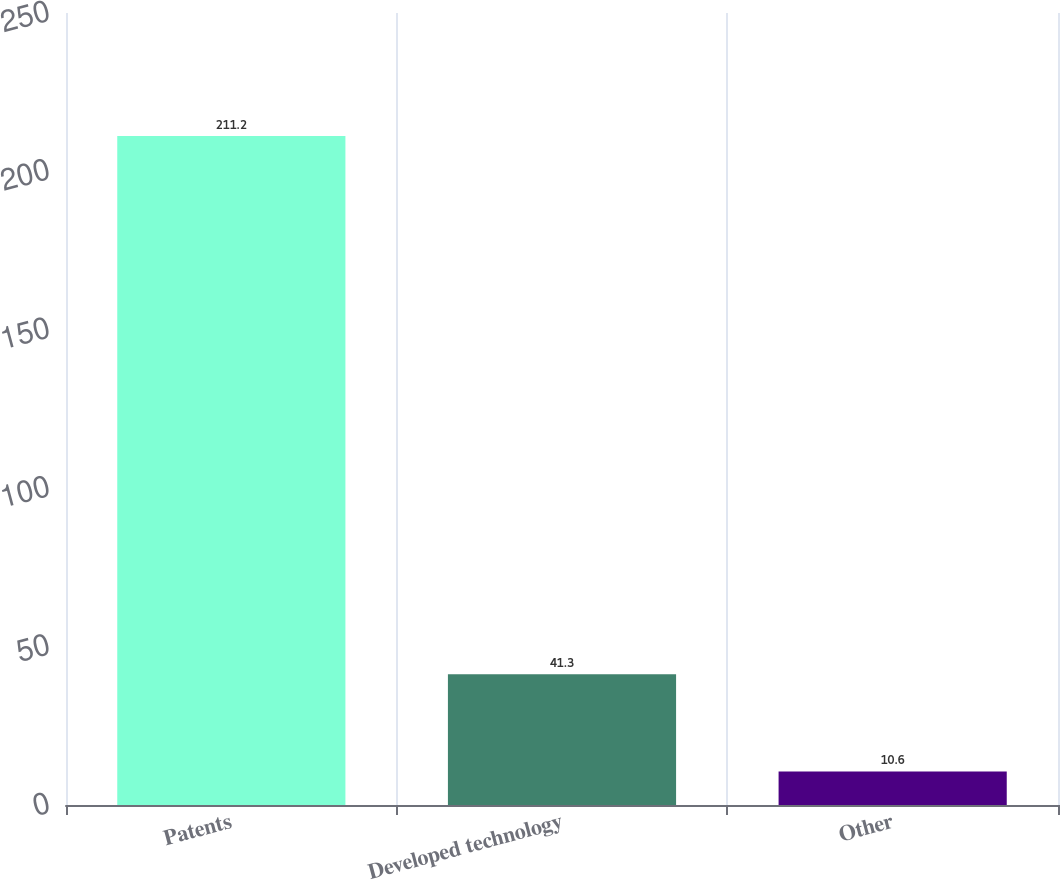Convert chart. <chart><loc_0><loc_0><loc_500><loc_500><bar_chart><fcel>Patents<fcel>Developed technology<fcel>Other<nl><fcel>211.2<fcel>41.3<fcel>10.6<nl></chart> 